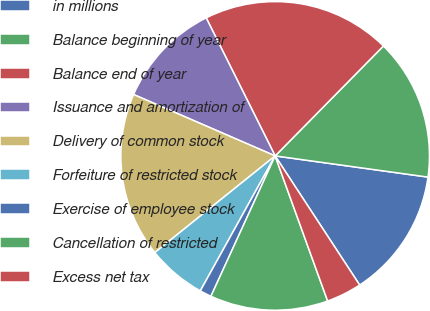Convert chart. <chart><loc_0><loc_0><loc_500><loc_500><pie_chart><fcel>in millions<fcel>Balance beginning of year<fcel>Balance end of year<fcel>Issuance and amortization of<fcel>Delivery of common stock<fcel>Forfeiture of restricted stock<fcel>Exercise of employee stock<fcel>Cancellation of restricted<fcel>Excess net tax<nl><fcel>13.58%<fcel>14.81%<fcel>19.75%<fcel>11.11%<fcel>17.28%<fcel>6.17%<fcel>1.23%<fcel>12.35%<fcel>3.7%<nl></chart> 